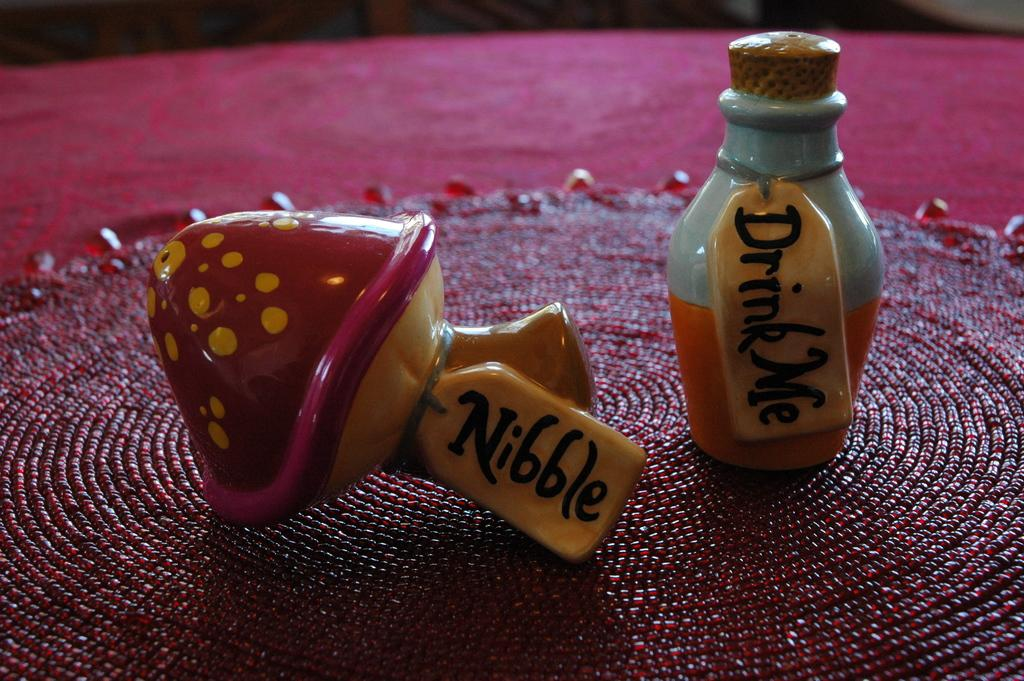<image>
Share a concise interpretation of the image provided. A ceramic mushroom and jug that says Nibble and Drink Me. 